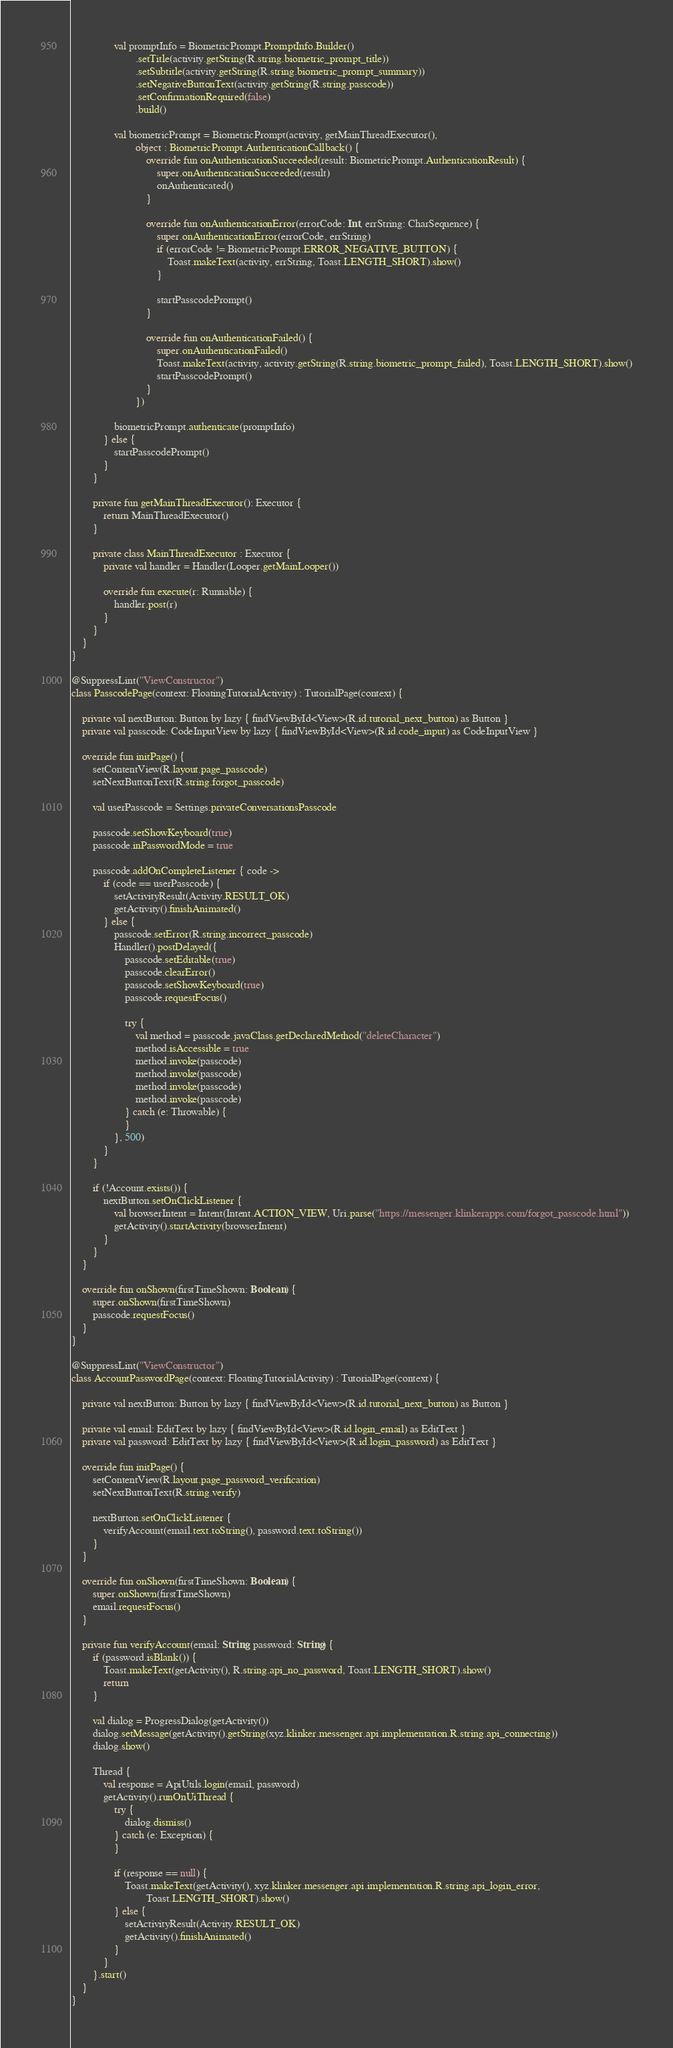Convert code to text. <code><loc_0><loc_0><loc_500><loc_500><_Kotlin_>                val promptInfo = BiometricPrompt.PromptInfo.Builder()
                        .setTitle(activity.getString(R.string.biometric_prompt_title))
                        .setSubtitle(activity.getString(R.string.biometric_prompt_summary))
                        .setNegativeButtonText(activity.getString(R.string.passcode))
                        .setConfirmationRequired(false)
                        .build()

                val biometricPrompt = BiometricPrompt(activity, getMainThreadExecutor(),
                        object : BiometricPrompt.AuthenticationCallback() {
                            override fun onAuthenticationSucceeded(result: BiometricPrompt.AuthenticationResult) {
                                super.onAuthenticationSucceeded(result)
                                onAuthenticated()
                            }

                            override fun onAuthenticationError(errorCode: Int, errString: CharSequence) {
                                super.onAuthenticationError(errorCode, errString)
                                if (errorCode != BiometricPrompt.ERROR_NEGATIVE_BUTTON) {
                                    Toast.makeText(activity, errString, Toast.LENGTH_SHORT).show()
                                }

                                startPasscodePrompt()
                            }

                            override fun onAuthenticationFailed() {
                                super.onAuthenticationFailed()
                                Toast.makeText(activity, activity.getString(R.string.biometric_prompt_failed), Toast.LENGTH_SHORT).show()
                                startPasscodePrompt()
                            }
                        })

                biometricPrompt.authenticate(promptInfo)
            } else {
                startPasscodePrompt()
            }
        }

        private fun getMainThreadExecutor(): Executor {
            return MainThreadExecutor()
        }

        private class MainThreadExecutor : Executor {
            private val handler = Handler(Looper.getMainLooper())

            override fun execute(r: Runnable) {
                handler.post(r)
            }
        }
    }
}

@SuppressLint("ViewConstructor")
class PasscodePage(context: FloatingTutorialActivity) : TutorialPage(context) {

    private val nextButton: Button by lazy { findViewById<View>(R.id.tutorial_next_button) as Button }
    private val passcode: CodeInputView by lazy { findViewById<View>(R.id.code_input) as CodeInputView }

    override fun initPage() {
        setContentView(R.layout.page_passcode)
        setNextButtonText(R.string.forgot_passcode)

        val userPasscode = Settings.privateConversationsPasscode

        passcode.setShowKeyboard(true)
        passcode.inPasswordMode = true

        passcode.addOnCompleteListener { code ->
            if (code == userPasscode) {
                setActivityResult(Activity.RESULT_OK)
                getActivity().finishAnimated()
            } else {
                passcode.setError(R.string.incorrect_passcode)
                Handler().postDelayed({
                    passcode.setEditable(true)
                    passcode.clearError()
                    passcode.setShowKeyboard(true)
                    passcode.requestFocus()

                    try {
                        val method = passcode.javaClass.getDeclaredMethod("deleteCharacter")
                        method.isAccessible = true
                        method.invoke(passcode)
                        method.invoke(passcode)
                        method.invoke(passcode)
                        method.invoke(passcode)
                    } catch (e: Throwable) {
                    }
                }, 500)
            }
        }

        if (!Account.exists()) {
            nextButton.setOnClickListener {
                val browserIntent = Intent(Intent.ACTION_VIEW, Uri.parse("https://messenger.klinkerapps.com/forgot_passcode.html"))
                getActivity().startActivity(browserIntent)
            }
        }
    }

    override fun onShown(firstTimeShown: Boolean) {
        super.onShown(firstTimeShown)
        passcode.requestFocus()
    }
}

@SuppressLint("ViewConstructor")
class AccountPasswordPage(context: FloatingTutorialActivity) : TutorialPage(context) {

    private val nextButton: Button by lazy { findViewById<View>(R.id.tutorial_next_button) as Button }

    private val email: EditText by lazy { findViewById<View>(R.id.login_email) as EditText }
    private val password: EditText by lazy { findViewById<View>(R.id.login_password) as EditText }

    override fun initPage() {
        setContentView(R.layout.page_password_verification)
        setNextButtonText(R.string.verify)

        nextButton.setOnClickListener {
            verifyAccount(email.text.toString(), password.text.toString())
        }
    }

    override fun onShown(firstTimeShown: Boolean) {
        super.onShown(firstTimeShown)
        email.requestFocus()
    }

    private fun verifyAccount(email: String, password: String) {
        if (password.isBlank()) {
            Toast.makeText(getActivity(), R.string.api_no_password, Toast.LENGTH_SHORT).show()
            return
        }

        val dialog = ProgressDialog(getActivity())
        dialog.setMessage(getActivity().getString(xyz.klinker.messenger.api.implementation.R.string.api_connecting))
        dialog.show()

        Thread {
            val response = ApiUtils.login(email, password)
            getActivity().runOnUiThread {
                try {
                    dialog.dismiss()
                } catch (e: Exception) {
                }

                if (response == null) {
                    Toast.makeText(getActivity(), xyz.klinker.messenger.api.implementation.R.string.api_login_error,
                            Toast.LENGTH_SHORT).show()
                } else {
                    setActivityResult(Activity.RESULT_OK)
                    getActivity().finishAnimated()
                }
            }
        }.start()
    }
}</code> 